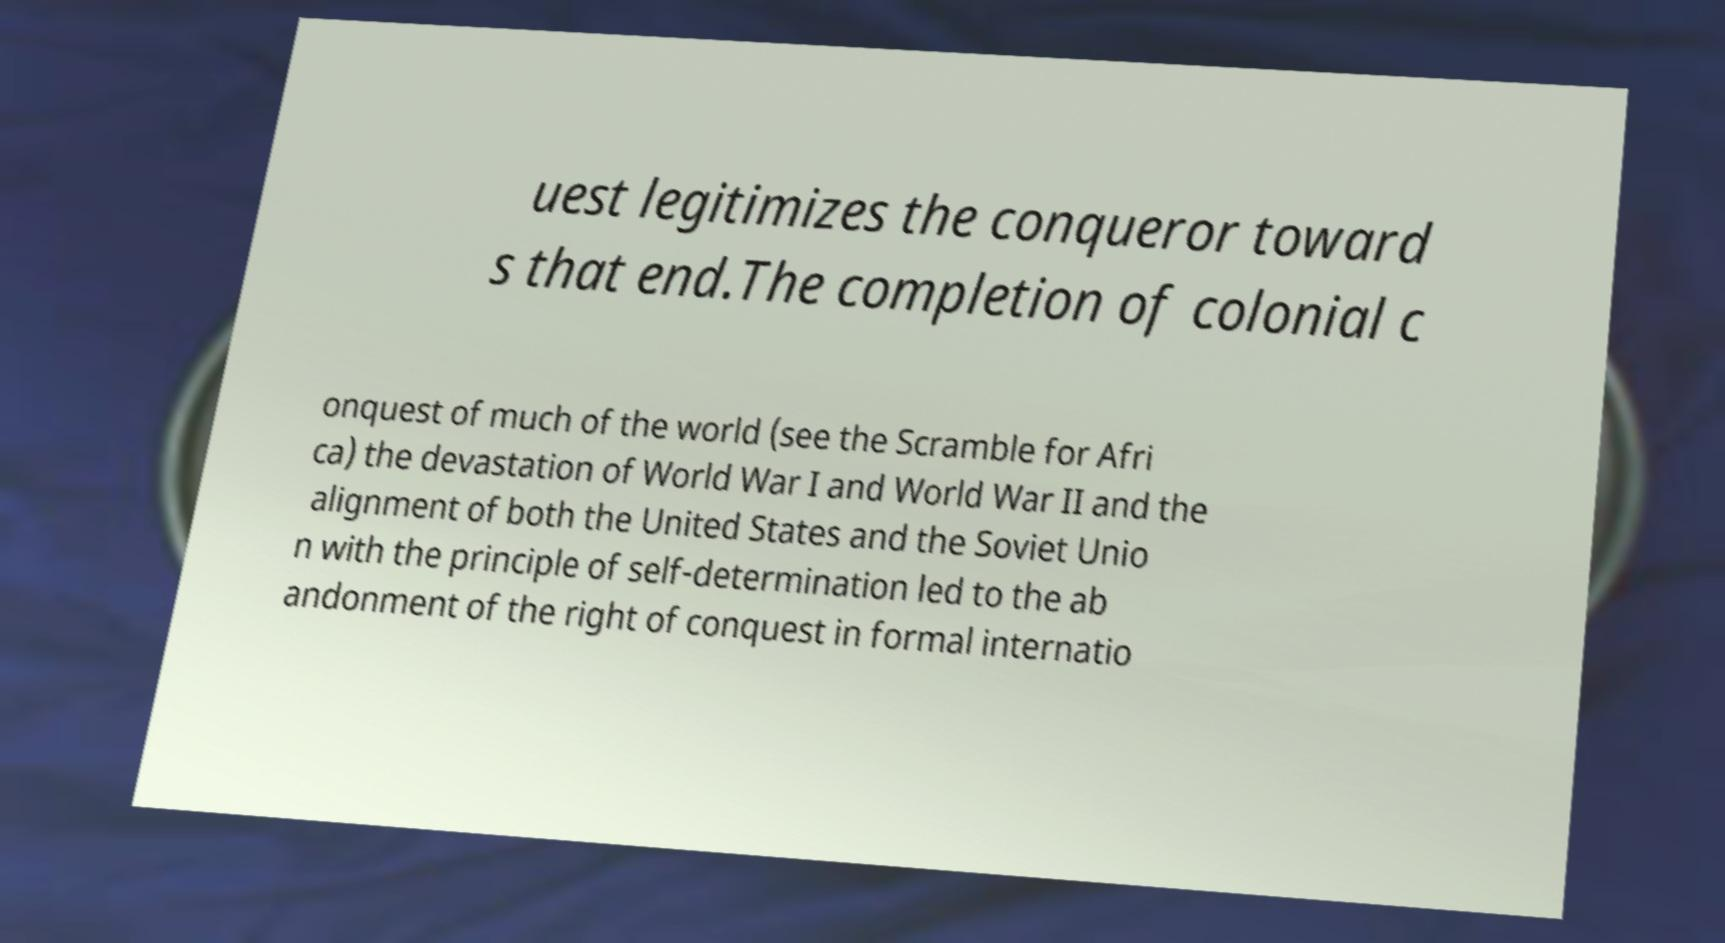Please read and relay the text visible in this image. What does it say? uest legitimizes the conqueror toward s that end.The completion of colonial c onquest of much of the world (see the Scramble for Afri ca) the devastation of World War I and World War II and the alignment of both the United States and the Soviet Unio n with the principle of self-determination led to the ab andonment of the right of conquest in formal internatio 